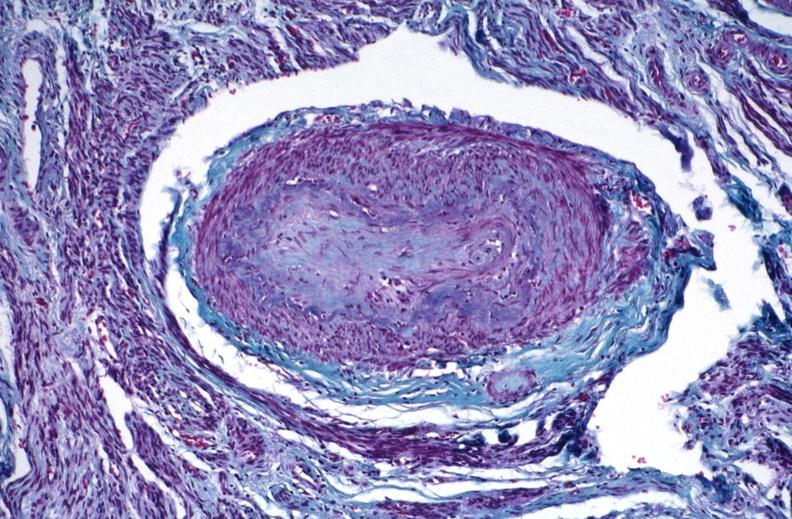what does this image show?
Answer the question using a single word or phrase. Kidney 